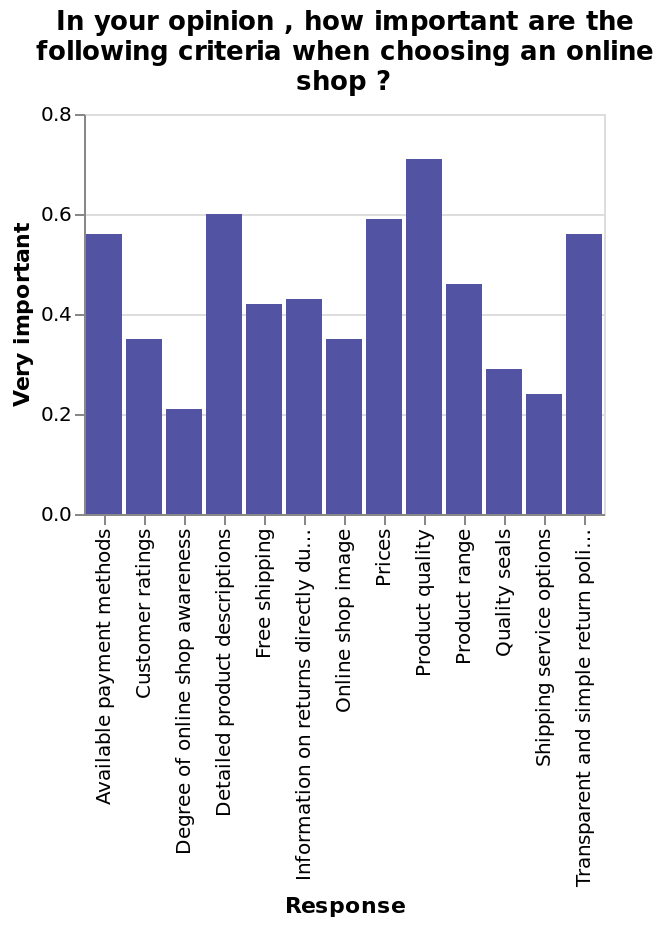<image>
What does the x-axis measure on the bar chart? The x-axis measures the response given for the different criteria when selecting an online shop. please describe the details of the chart In your opinion , how important are the following criteria when choosing an online shop ? is a bar chart. The y-axis shows Very important while the x-axis measures Response. What is the most important factor for consumers when making a choice? Product quality is the most important factor. Offer a thorough analysis of the image. The most important criteria to the customers was product quality. Prices, a transparent return policy and detailed product descriptions were then all fairly of equal importance but the most important after quality. Online shop awareness and shipping service options were the least important criteria. What factors follow product quality in terms of influence on consumer choice? Product description and price follow product quality in terms of influence on consumer choice. 